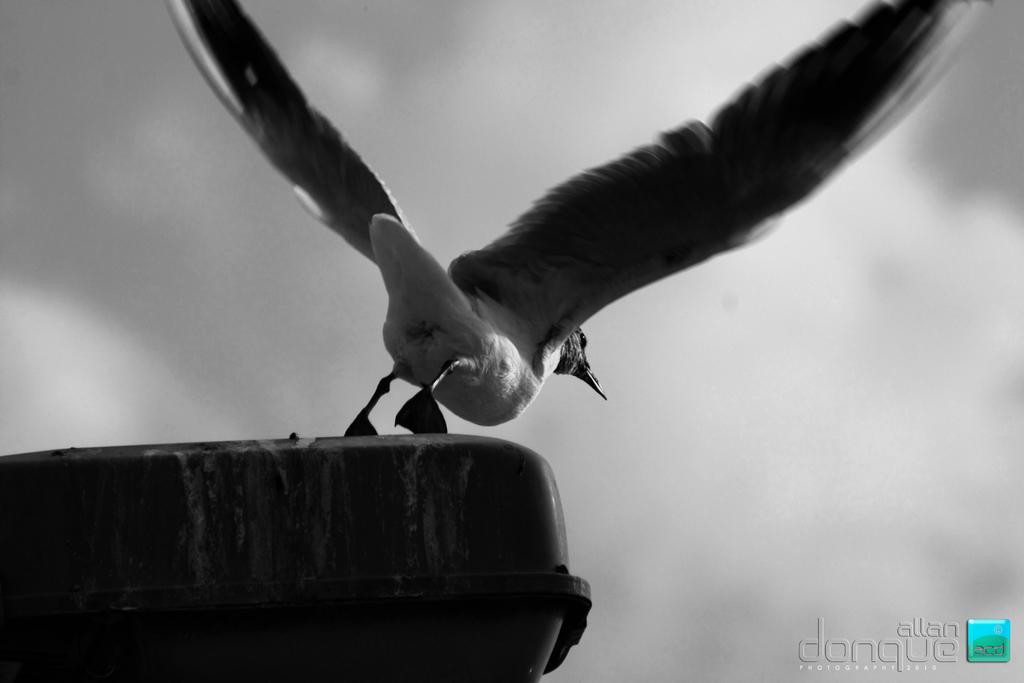What is the color scheme of the image? The image is black and white. What is the main subject in the center of the image? There is a bird in the center of the image. What object can be seen at the bottom of the image? There is an object at the bottom of the image. How would you describe the sky in the image? The sky is cloudy in the image. What type of pest can be seen crawling on the bird in the image? There are no pests visible in the image, and the bird is not being crawled on by any creature. What class is the bird attending in the image? The image does not depict a bird attending a class; it is a still image of a bird in the center of the frame. 